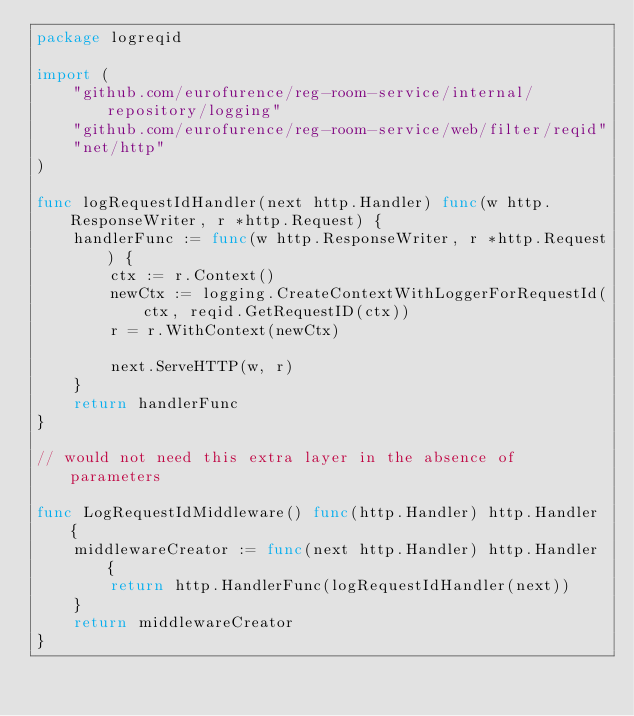Convert code to text. <code><loc_0><loc_0><loc_500><loc_500><_Go_>package logreqid

import (
	"github.com/eurofurence/reg-room-service/internal/repository/logging"
	"github.com/eurofurence/reg-room-service/web/filter/reqid"
	"net/http"
)

func logRequestIdHandler(next http.Handler) func(w http.ResponseWriter, r *http.Request) {
	handlerFunc := func(w http.ResponseWriter, r *http.Request) {
		ctx := r.Context()
		newCtx := logging.CreateContextWithLoggerForRequestId(ctx, reqid.GetRequestID(ctx))
		r = r.WithContext(newCtx)

		next.ServeHTTP(w, r)
	}
	return handlerFunc
}

// would not need this extra layer in the absence of parameters

func LogRequestIdMiddleware() func(http.Handler) http.Handler {
	middlewareCreator := func(next http.Handler) http.Handler {
		return http.HandlerFunc(logRequestIdHandler(next))
	}
	return middlewareCreator
}
</code> 